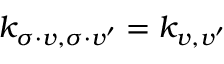<formula> <loc_0><loc_0><loc_500><loc_500>k _ { \sigma \cdot v , \sigma \cdot v ^ { \prime } } = k _ { v , v ^ { \prime } }</formula> 